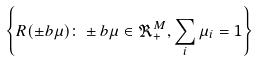<formula> <loc_0><loc_0><loc_500><loc_500>\left \{ R ( \pm b { \mu } ) \colon \pm b { \mu } \in \Re ^ { M } _ { + } , \sum _ { i } \mu _ { i } = 1 \right \}</formula> 